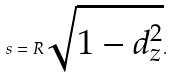Convert formula to latex. <formula><loc_0><loc_0><loc_500><loc_500>s = R \sqrt { 1 - d _ { z } ^ { 2 } } .</formula> 